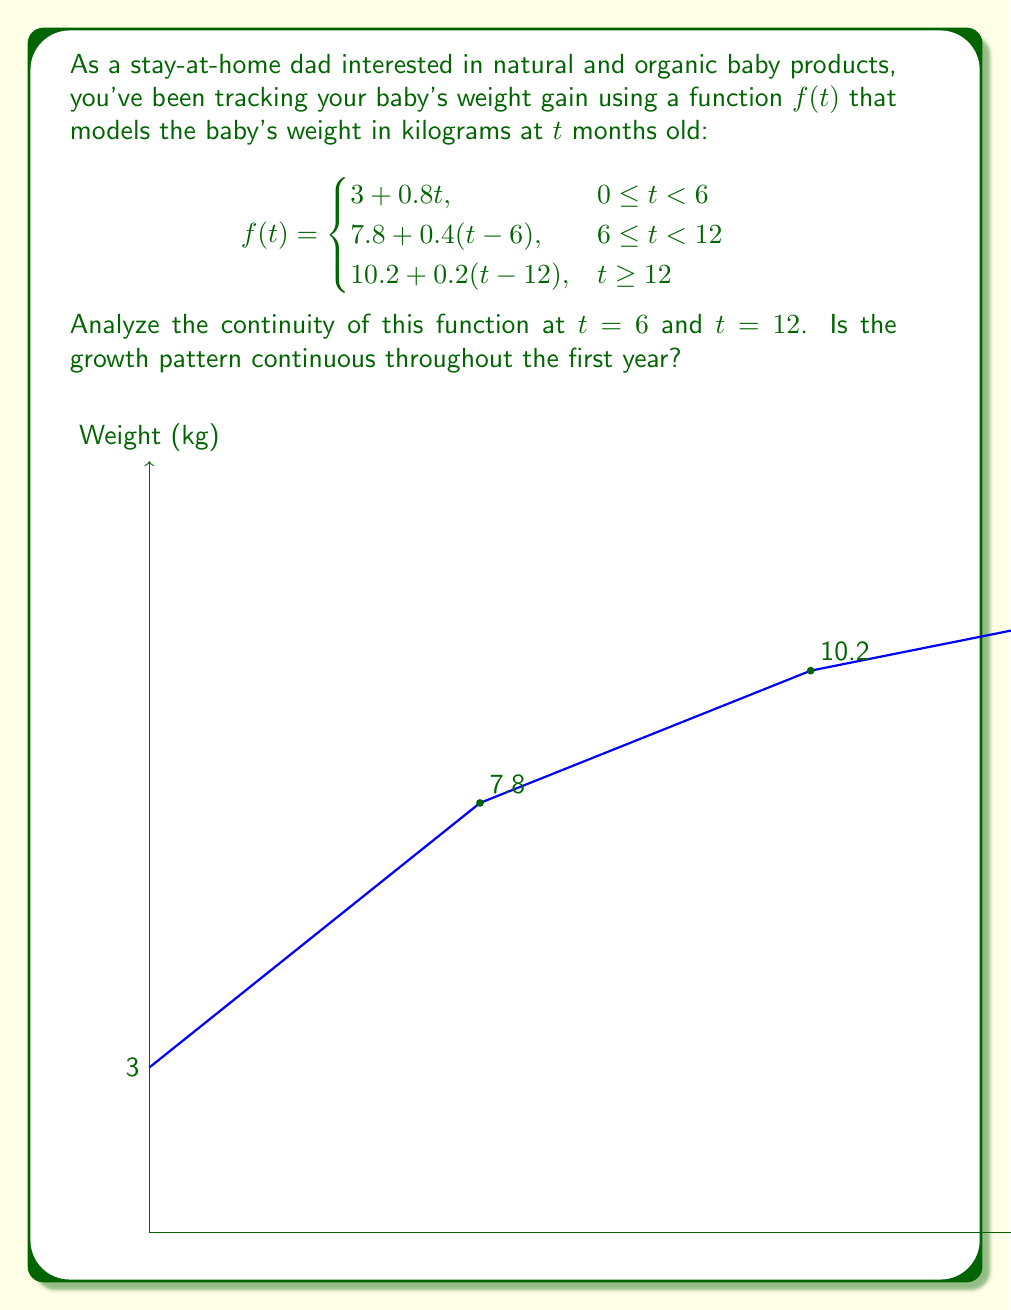Provide a solution to this math problem. To analyze the continuity of the function at $t = 6$ and $t = 12$, we need to check if the function satisfies the three conditions for continuity at these points:

1. The function is defined at the point.
2. The limit of the function exists as we approach the point from both sides.
3. The limit equals the function value at that point.

For $t = 6$:

1. $f(6)$ is defined: $f(6) = 7.8$ (using the second piece of the function)
2. Left-hand limit: $\lim_{t \to 6^-} f(t) = \lim_{t \to 6^-} (3 + 0.8t) = 3 + 0.8(6) = 7.8$
   Right-hand limit: $\lim_{t \to 6^+} f(t) = \lim_{t \to 6^+} (7.8 + 0.4(t-6)) = 7.8 + 0.4(0) = 7.8$
3. Both limits equal $f(6) = 7.8$

Therefore, $f(t)$ is continuous at $t = 6$.

For $t = 12$:

1. $f(12)$ is defined: $f(12) = 10.2$ (using the third piece of the function)
2. Left-hand limit: $\lim_{t \to 12^-} f(t) = \lim_{t \to 12^-} (7.8 + 0.4(t-6)) = 7.8 + 0.4(6) = 10.2$
   Right-hand limit: $\lim_{t \to 12^+} f(t) = \lim_{t \to 12^+} (10.2 + 0.2(t-12)) = 10.2 + 0.2(0) = 10.2$
3. Both limits equal $f(12) = 10.2$

Therefore, $f(t)$ is continuous at $t = 12$.

Since the function is continuous at both $t = 6$ and $t = 12$, and it's composed of continuous linear pieces between these points, the growth pattern is continuous throughout the first year and beyond.
Answer: The function is continuous at $t = 6$ and $t = 12$, and the growth pattern is continuous throughout the first year. 